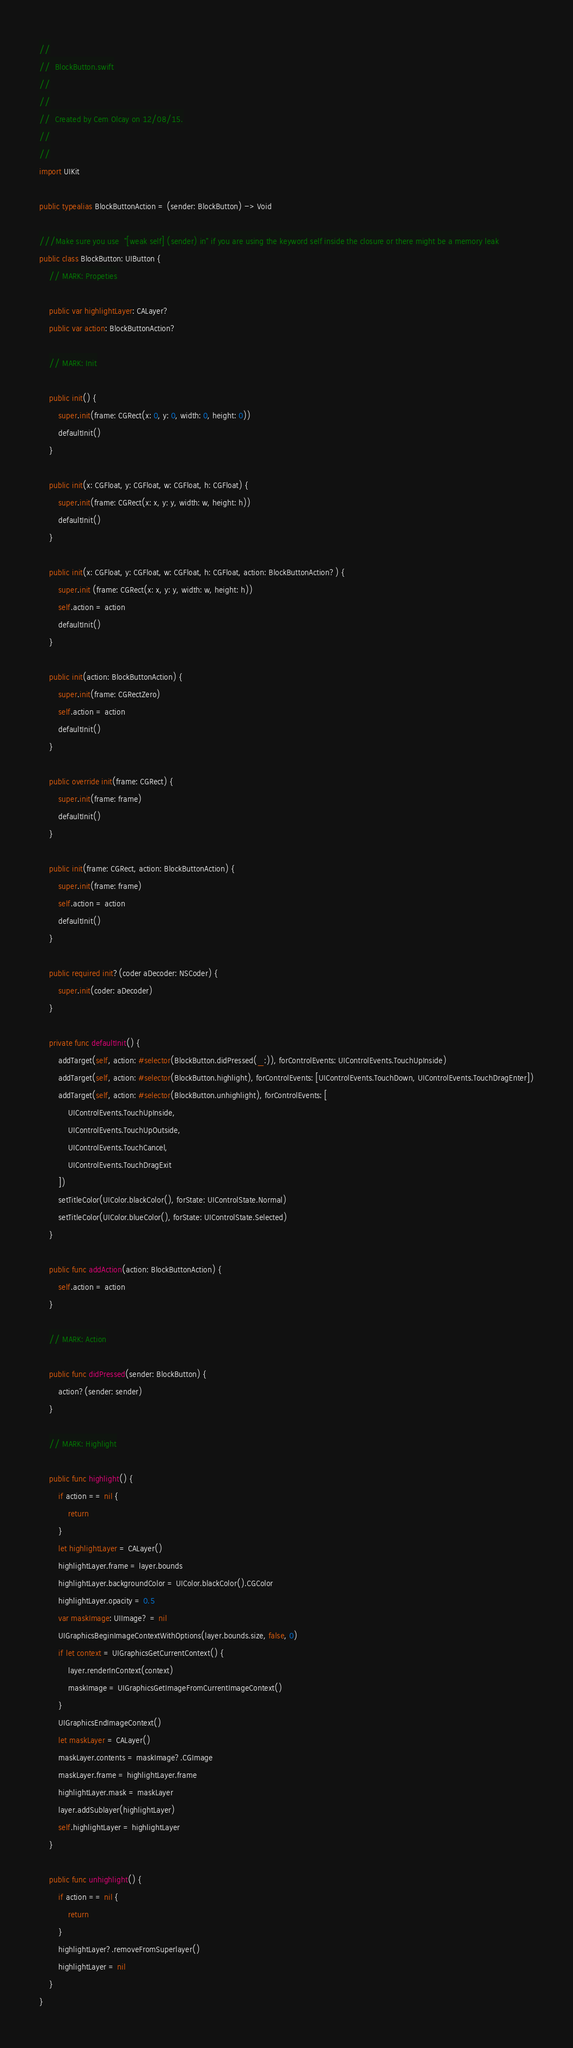Convert code to text. <code><loc_0><loc_0><loc_500><loc_500><_Swift_>//
//  BlockButton.swift
//
//
//  Created by Cem Olcay on 12/08/15.
//
//
import UIKit

public typealias BlockButtonAction = (sender: BlockButton) -> Void

///Make sure you use  "[weak self] (sender) in" if you are using the keyword self inside the closure or there might be a memory leak
public class BlockButton: UIButton {
    // MARK: Propeties

    public var highlightLayer: CALayer?
    public var action: BlockButtonAction?

    // MARK: Init

    public init() {
        super.init(frame: CGRect(x: 0, y: 0, width: 0, height: 0))
        defaultInit()
    }

    public init(x: CGFloat, y: CGFloat, w: CGFloat, h: CGFloat) {
        super.init(frame: CGRect(x: x, y: y, width: w, height: h))
        defaultInit()
    }

    public init(x: CGFloat, y: CGFloat, w: CGFloat, h: CGFloat, action: BlockButtonAction?) {
        super.init (frame: CGRect(x: x, y: y, width: w, height: h))
        self.action = action
        defaultInit()
    }

    public init(action: BlockButtonAction) {
        super.init(frame: CGRectZero)
        self.action = action
        defaultInit()
    }

    public override init(frame: CGRect) {
        super.init(frame: frame)
        defaultInit()
    }

    public init(frame: CGRect, action: BlockButtonAction) {
        super.init(frame: frame)
        self.action = action
        defaultInit()
    }

    public required init?(coder aDecoder: NSCoder) {
        super.init(coder: aDecoder)
    }

    private func defaultInit() {
        addTarget(self, action: #selector(BlockButton.didPressed(_:)), forControlEvents: UIControlEvents.TouchUpInside)
        addTarget(self, action: #selector(BlockButton.highlight), forControlEvents: [UIControlEvents.TouchDown, UIControlEvents.TouchDragEnter])
        addTarget(self, action: #selector(BlockButton.unhighlight), forControlEvents: [
            UIControlEvents.TouchUpInside,
            UIControlEvents.TouchUpOutside,
            UIControlEvents.TouchCancel,
            UIControlEvents.TouchDragExit
        ])
        setTitleColor(UIColor.blackColor(), forState: UIControlState.Normal)
        setTitleColor(UIColor.blueColor(), forState: UIControlState.Selected)
    }

    public func addAction(action: BlockButtonAction) {
        self.action = action
    }

    // MARK: Action

    public func didPressed(sender: BlockButton) {
        action?(sender: sender)
    }

    // MARK: Highlight

    public func highlight() {
        if action == nil {
            return
        }
        let highlightLayer = CALayer()
        highlightLayer.frame = layer.bounds
        highlightLayer.backgroundColor = UIColor.blackColor().CGColor
        highlightLayer.opacity = 0.5
        var maskImage: UIImage? = nil
        UIGraphicsBeginImageContextWithOptions(layer.bounds.size, false, 0)
        if let context = UIGraphicsGetCurrentContext() {
            layer.renderInContext(context)
            maskImage = UIGraphicsGetImageFromCurrentImageContext()
        }
        UIGraphicsEndImageContext()
        let maskLayer = CALayer()
        maskLayer.contents = maskImage?.CGImage
        maskLayer.frame = highlightLayer.frame
        highlightLayer.mask = maskLayer
        layer.addSublayer(highlightLayer)
        self.highlightLayer = highlightLayer
    }

    public func unhighlight() {
        if action == nil {
            return
        }
        highlightLayer?.removeFromSuperlayer()
        highlightLayer = nil
    }
}
</code> 